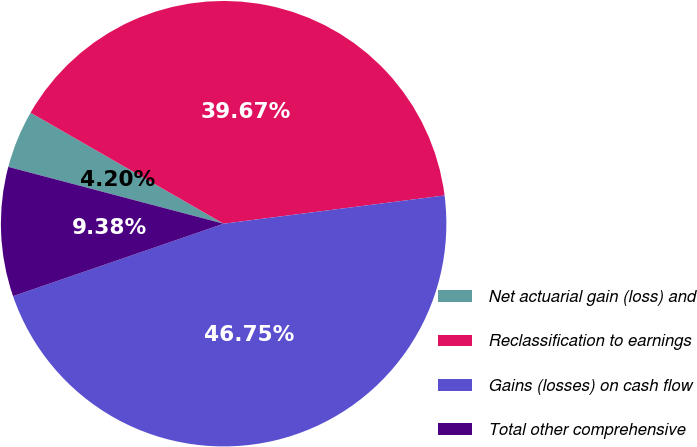<chart> <loc_0><loc_0><loc_500><loc_500><pie_chart><fcel>Net actuarial gain (loss) and<fcel>Reclassification to earnings<fcel>Gains (losses) on cash flow<fcel>Total other comprehensive<nl><fcel>4.2%<fcel>39.67%<fcel>46.75%<fcel>9.38%<nl></chart> 